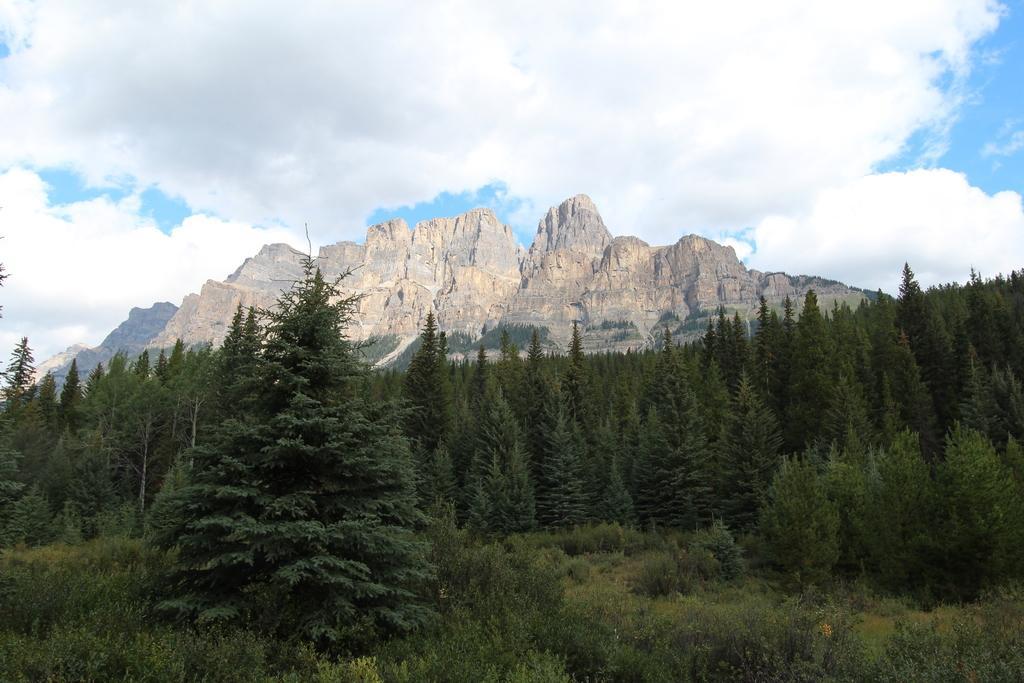Can you describe this image briefly? In this picture there is a beautiful view of the mountains. In the front bottom side there are many trees. On the top we can see the sky. 